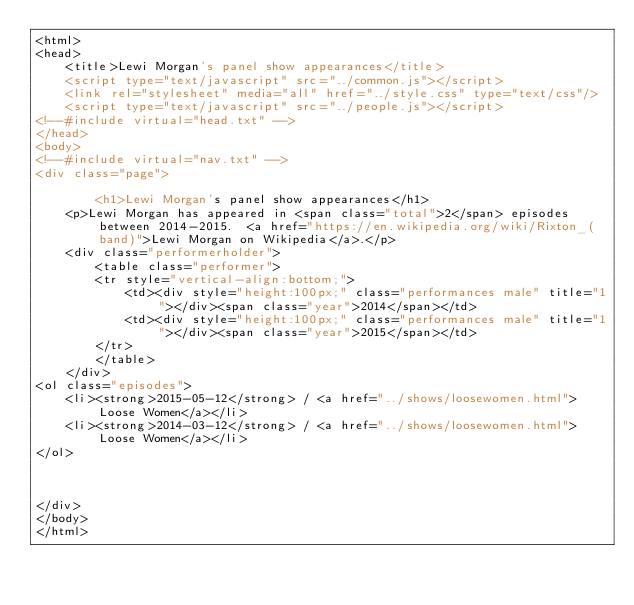<code> <loc_0><loc_0><loc_500><loc_500><_HTML_><html>
<head>
	<title>Lewi Morgan's panel show appearances</title>
	<script type="text/javascript" src="../common.js"></script>
	<link rel="stylesheet" media="all" href="../style.css" type="text/css"/>
	<script type="text/javascript" src="../people.js"></script>
<!--#include virtual="head.txt" -->
</head>
<body>
<!--#include virtual="nav.txt" -->
<div class="page">

		<h1>Lewi Morgan's panel show appearances</h1>
	<p>Lewi Morgan has appeared in <span class="total">2</span> episodes between 2014-2015.  <a href="https://en.wikipedia.org/wiki/Rixton_(band)">Lewi Morgan on Wikipedia</a>.</p>
	<div class="performerholder">
		<table class="performer">
		<tr style="vertical-align:bottom;">
			<td><div style="height:100px;" class="performances male" title="1"></div><span class="year">2014</span></td>
			<td><div style="height:100px;" class="performances male" title="1"></div><span class="year">2015</span></td>
		</tr>
		</table>
	</div>
<ol class="episodes">
	<li><strong>2015-05-12</strong> / <a href="../shows/loosewomen.html">Loose Women</a></li>
	<li><strong>2014-03-12</strong> / <a href="../shows/loosewomen.html">Loose Women</a></li>
</ol>



</div>
</body>
</html>
</code> 